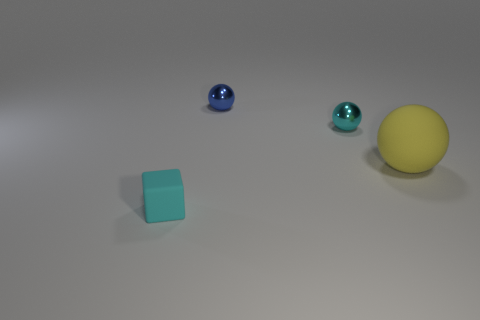Subtract all blue spheres. How many spheres are left? 2 Add 2 tiny brown cylinders. How many objects exist? 6 Subtract all balls. How many objects are left? 1 Subtract all cyan matte blocks. Subtract all small green rubber cubes. How many objects are left? 3 Add 4 yellow things. How many yellow things are left? 5 Add 1 purple things. How many purple things exist? 1 Subtract 0 blue cylinders. How many objects are left? 4 Subtract all blue cubes. Subtract all gray balls. How many cubes are left? 1 